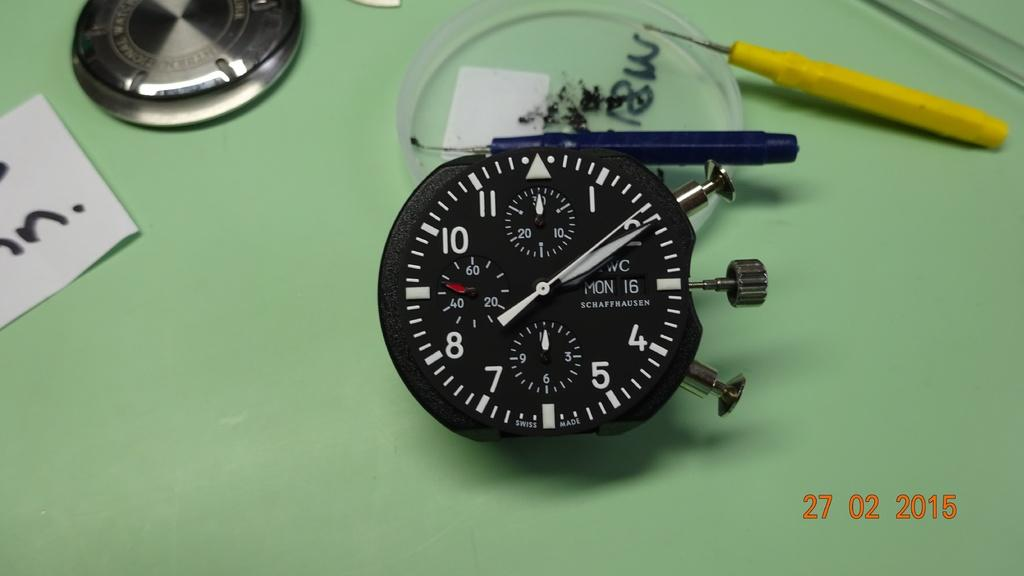<image>
Describe the image concisely. A Swiss made timer has Mon the 16th on the face. 